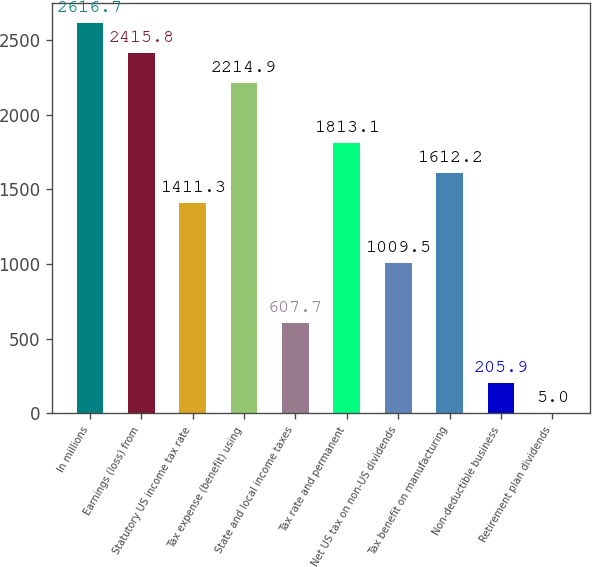<chart> <loc_0><loc_0><loc_500><loc_500><bar_chart><fcel>In millions<fcel>Earnings (loss) from<fcel>Statutory US income tax rate<fcel>Tax expense (benefit) using<fcel>State and local income taxes<fcel>Tax rate and permanent<fcel>Net US tax on non-US dividends<fcel>Tax benefit on manufacturing<fcel>Non-deductible business<fcel>Retirement plan dividends<nl><fcel>2616.7<fcel>2415.8<fcel>1411.3<fcel>2214.9<fcel>607.7<fcel>1813.1<fcel>1009.5<fcel>1612.2<fcel>205.9<fcel>5<nl></chart> 